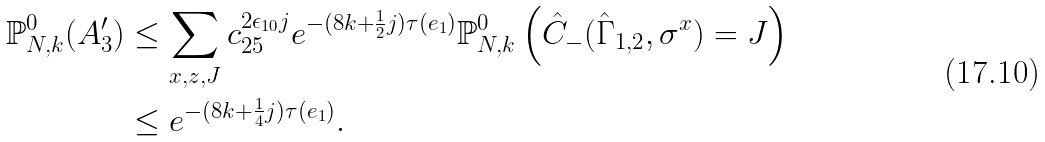<formula> <loc_0><loc_0><loc_500><loc_500>\mathbb { P } ^ { 0 } _ { N , k } ( A _ { 3 } ^ { \prime } ) & \leq \sum _ { x , z , J } c _ { 2 5 } ^ { 2 \epsilon _ { 1 0 } j } e ^ { - ( 8 k + \frac { 1 } { 2 } j ) \tau ( e _ { 1 } ) } \mathbb { P } ^ { 0 } _ { N , k } \left ( \hat { C } _ { - } ( \hat { \Gamma } _ { 1 , 2 } , \sigma ^ { x } ) = J \right ) \\ & \leq e ^ { - ( 8 k + \frac { 1 } { 4 } j ) \tau ( e _ { 1 } ) } .</formula> 